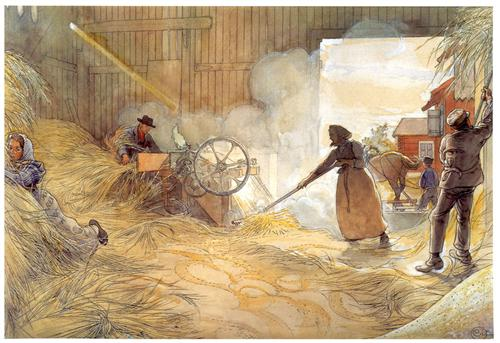If this scene were part of a fantasy novel, what fantastical elements might it include? If this scene were part of a fantasy novel, it might include magical elements such as enchanted tools that make the work easier or more efficient. Perhaps the threshing machine hums with a magical energy, powered by an ancient spell, and the straw glows softly as it is separated from the grain. The workers might be aided by friendly forest spirits or talking animals that help carry out the tasks. The barn itself could be a sentient structure, responding to the needs of the workers and providing them with warmth and protection. As the day progresses, the beams of light streaming into the barn might reveal hidden messages or ancient runes, hinting at a forgotten history or a mystical quest that the workers are unknowingly intertwined with. 